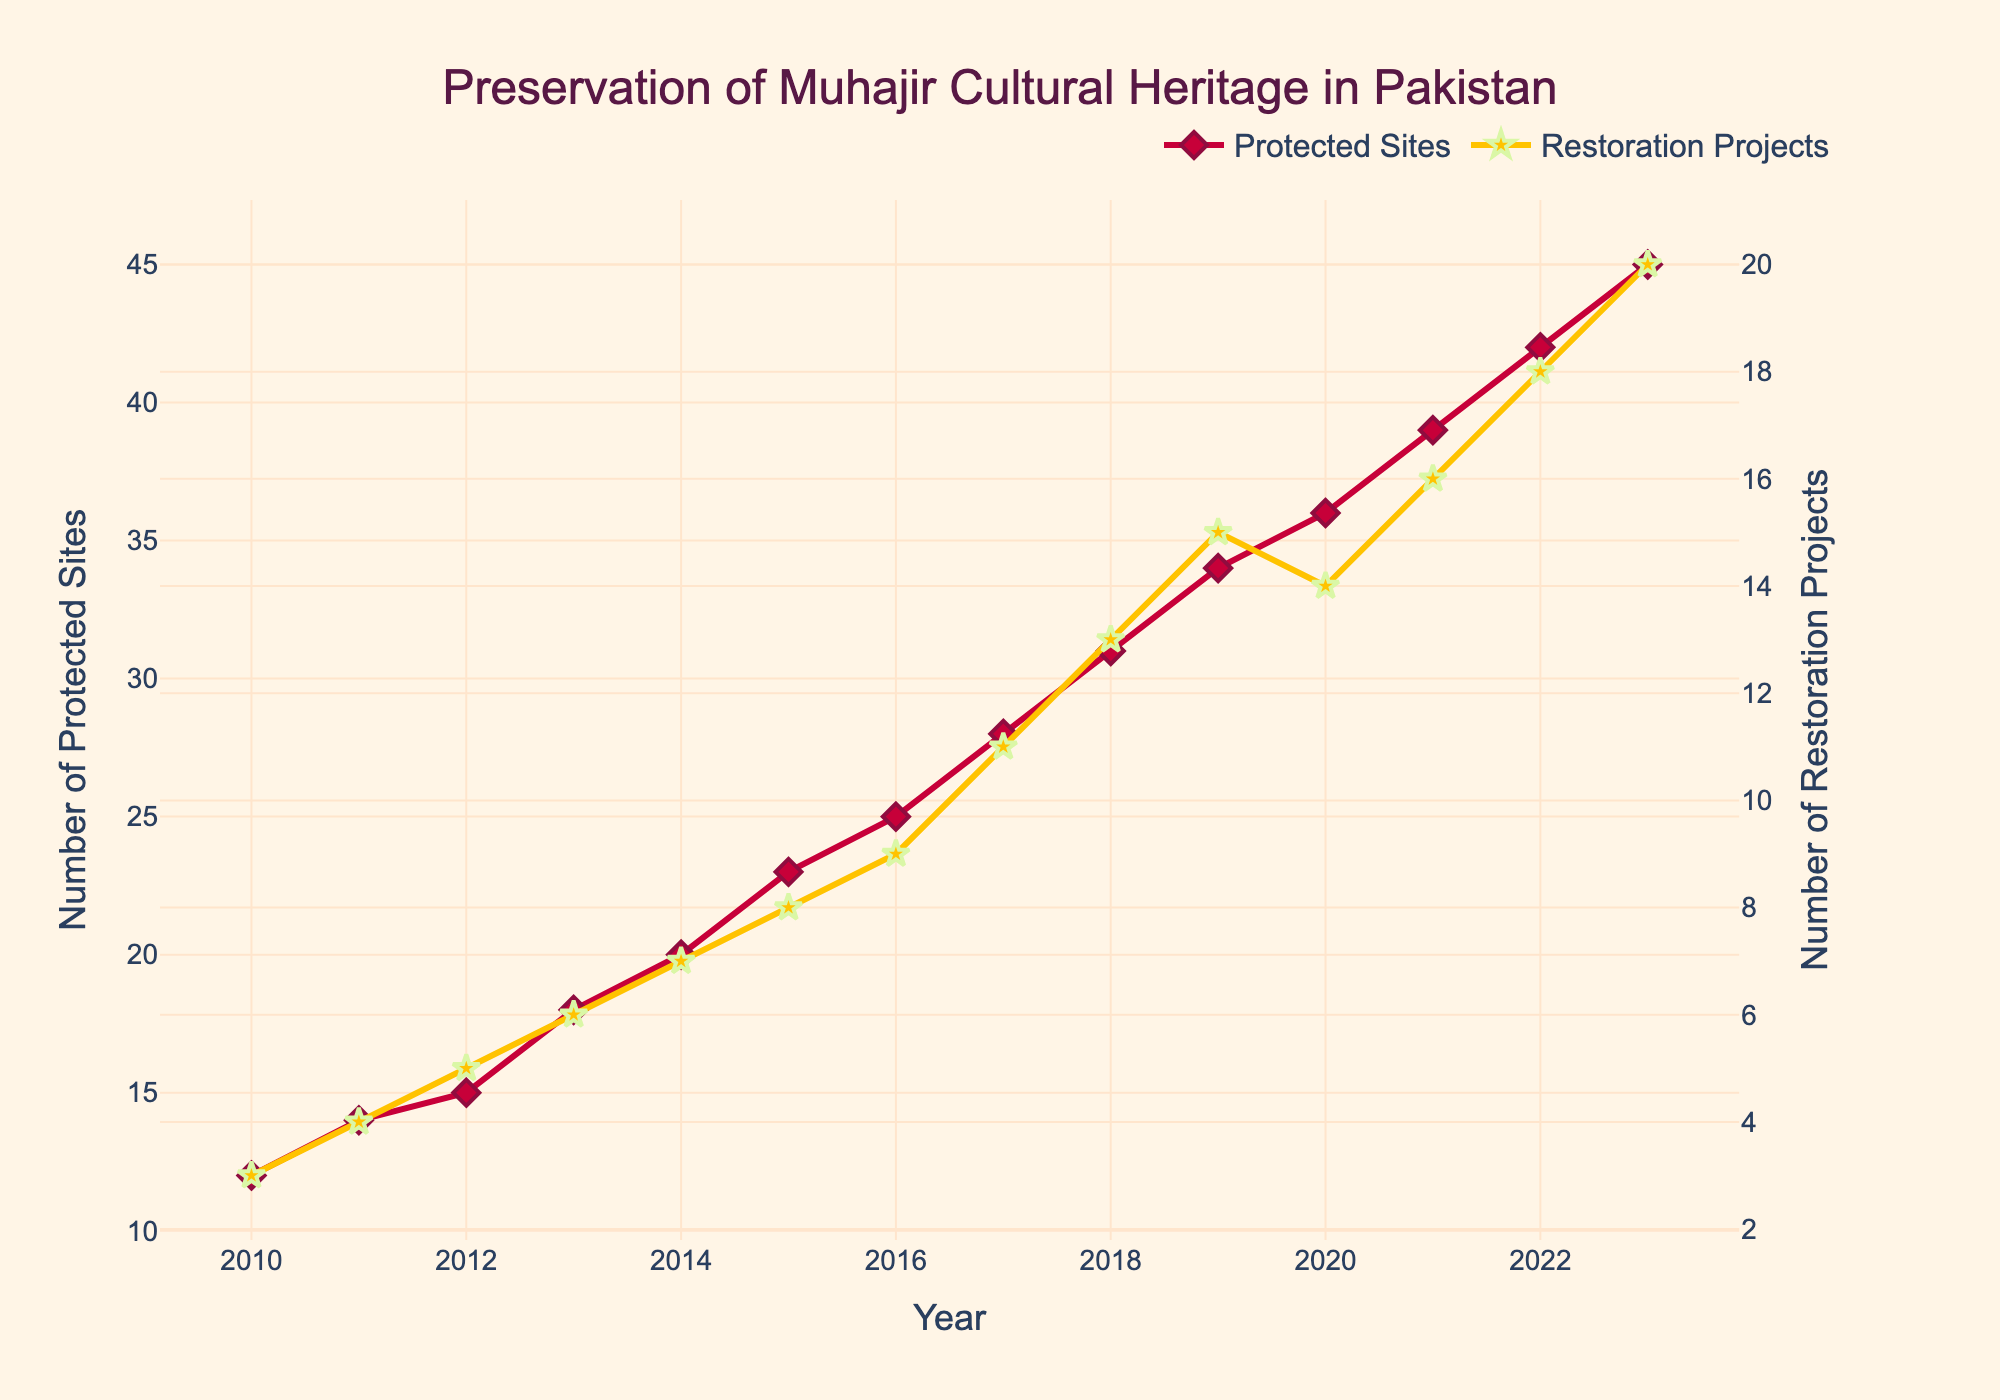What's the total number of protected sites by 2020? To find the total number of protected sites by 2020, locate the data point for the year 2020 from the figure. The value is 36.
Answer: 36 How many restoration projects were conducted in 2016 and 2017 combined? For this question, identify the number of restoration projects for the years 2016 and 2017 from the figure. The values are 9 and 11 respectively. Summing them up gives 9 + 11 = 20.
Answer: 20 Between which consecutive years was the increase in the number of protected sites the highest? Refer to the figure to compare the increments in the number of protected sites between consecutive years. The largest increase is between 2018 (31) and 2019 (34). The change is 34 - 31 = 3.
Answer: 2018 and 2019 Which year had the highest number of restoration projects? Locate the year with the highest value on the vertical axis representing restoration projects. The highest value is 20 in the year 2023.
Answer: 2023 Calculate the average number of protected sites from 2010 to 2015. Find the sum of the number of protected sites from the years 2010 to 2015: 12 + 14 + 15 + 18 + 20 + 23 = 102. Then divide by the number of years (6) to get 102 / 6 = 17.
Answer: 17 Were there more restoration projects or protected sites in 2014? Compare the data for 2014, where there were 20 protected sites and 7 restoration projects. 20 is greater than 7.
Answer: Protected Sites What is the difference in the number of protected sites between 2010 and 2023? Subtract the number of protected sites in 2010 from that in 2023. 45 - 12 = 33.
Answer: 33 How did the number of restoration projects change from 2019 to 2020? Compare the number of restoration projects in 2019 (15) to that in 2020 (14). The change is 14 - 15 = -1, indicating a decrease.
Answer: Decreased by 1 If the trend continues, how many protected sites would you expect in 2024? From the figure, the number of protected sites has been increasing consistently. From 2022 to 2023, it increased by 3. Using this rate, expected number of protected sites in 2024 would be 45 + 3 = 48.
Answer: 48 